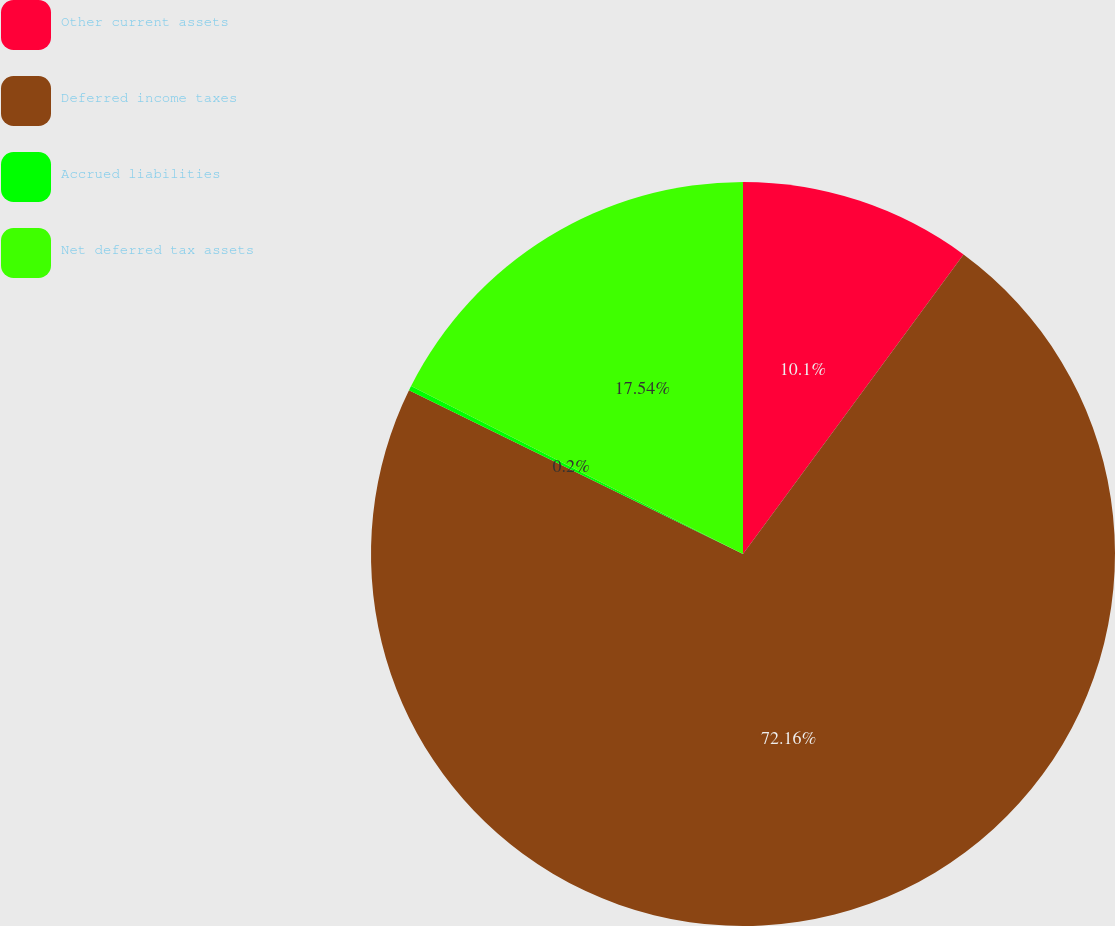<chart> <loc_0><loc_0><loc_500><loc_500><pie_chart><fcel>Other current assets<fcel>Deferred income taxes<fcel>Accrued liabilities<fcel>Net deferred tax assets<nl><fcel>10.1%<fcel>72.15%<fcel>0.2%<fcel>17.54%<nl></chart> 